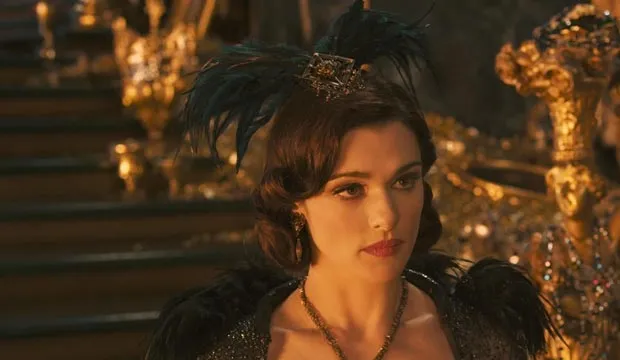Imagine a scenario where Evanora is plotting her next move. Can you describe that scene? In a dimly lit chamber filled with ancient scrolls and mystical artifacts, Evanora stands beside a large, ornate table. Her eyes scan a detailed map of Oz, her fingers tracing the borders of the territories she aims to conquer. The flickering candlelight casts shadows on her determined face, revealing the intensity of her ambition. She whispers incantations under her breath, focusing her power for the challenges that lie ahead. 